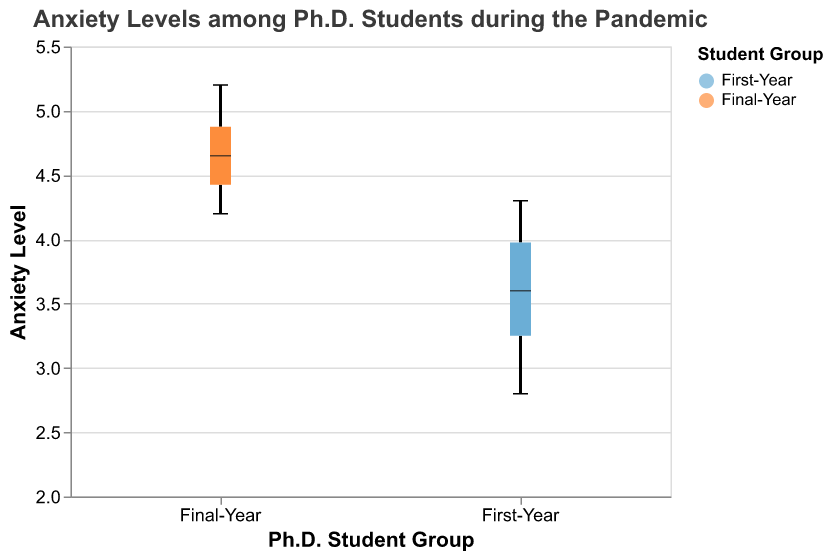What's the title of the figure? The title is located at the top of the figure, indicating the main topic or content of the chart. In this case, it clearly states the subject as "Anxiety Levels among Ph.D. Students during the Pandemic."
Answer: Anxiety Levels among Ph.D. Students during the Pandemic Which student group has the higher median anxiety level? To determine this, locate the median line inside each boxplot. The Final-Year group has a higher median line compared to the First-Year group.
Answer: Final-Year What is the median anxiety level for First-Year Ph.D. students? Identify the median line within the First-Year boxplot. The median line corresponds to the middle value of an ordered data set and is typically represented as a line or bar inside the box.
Answer: 3.65 How does the variability in anxiety levels compare between the two groups? Observe the height of the boxes and the range from the bottom whisker to the top whisker for both groups. The Final-Year group shows a higher degree of spread or variability in anxiety levels compared to the First-Year group.
Answer: Final-Year group has higher variability What is the range of anxiety levels for the Final-Year group? The range is determined by subtracting the minimum value (represented by the bottom whisker) from the maximum value (represented by the top whisker). Thus, for the Final-Year group, it ranges from 4.2 to 5.2.
Answer: 1.0 Which group has a wider interquartile range (IQR) of anxiety levels? The IQR is the range between the first quartile (Q1) and the third quartile (Q3) of the data. By examining the height of each group's box, the Final-Year group has a wider IQR compared to the First-Year group.
Answer: Final-Year What is the median anxiety level for Final-Year Ph.D. students? The median is identified by the line within the Final-Year boxplot, which represents the central value of the sorted anxiety levels data.
Answer: 4.65 How many data points are there for each student group? By counting the number of individual circles or dots which often represent data outliers or by knowing there are 10 entries per group as provided, each group has an equal number of data points.
Answer: 10 for each group Comparing both groups, which one shows a higher minimum anxiety level? Identify the bottom whisker for both boxplots, which represents the minimum value. The Final-Year group has a higher bottom whisker, indicating a higher minimum anxiety level.
Answer: Final-Year What is depicted by the color of the boxplots in the figure? Colors distinguish the two groups. The First-Year students are represented with a blue shade, whereas the Final-Year students are represented with an orange shade. This color differentiation helps in visually comparing the groups.
Answer: The groups (First-Year vs. Final-Year) 